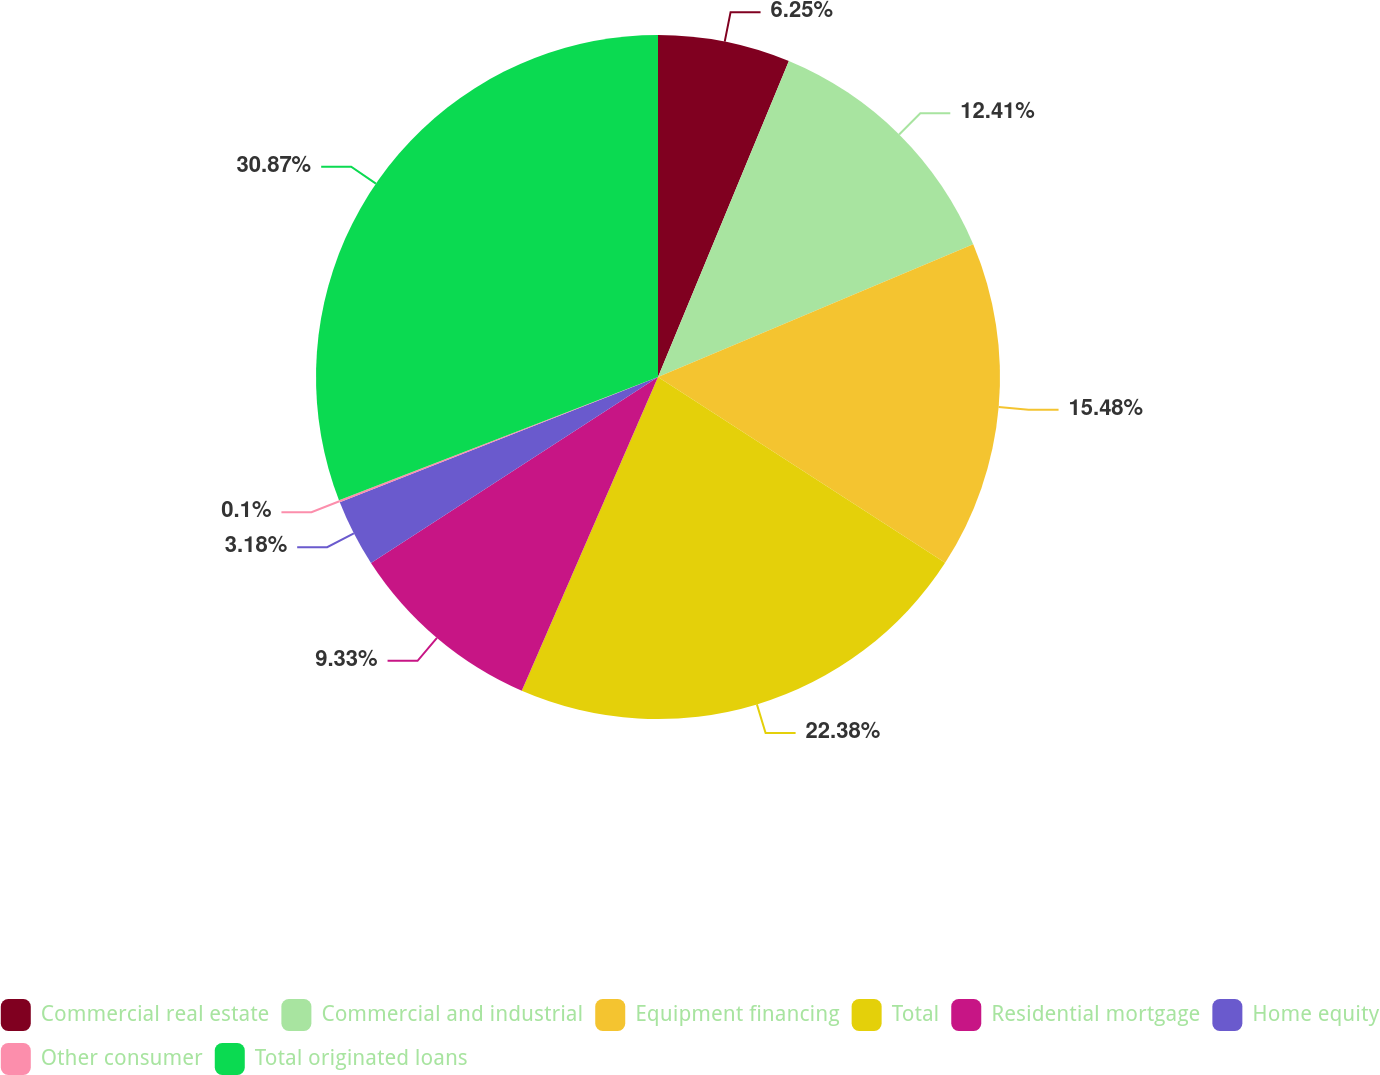<chart> <loc_0><loc_0><loc_500><loc_500><pie_chart><fcel>Commercial real estate<fcel>Commercial and industrial<fcel>Equipment financing<fcel>Total<fcel>Residential mortgage<fcel>Home equity<fcel>Other consumer<fcel>Total originated loans<nl><fcel>6.25%<fcel>12.41%<fcel>15.48%<fcel>22.38%<fcel>9.33%<fcel>3.18%<fcel>0.1%<fcel>30.87%<nl></chart> 